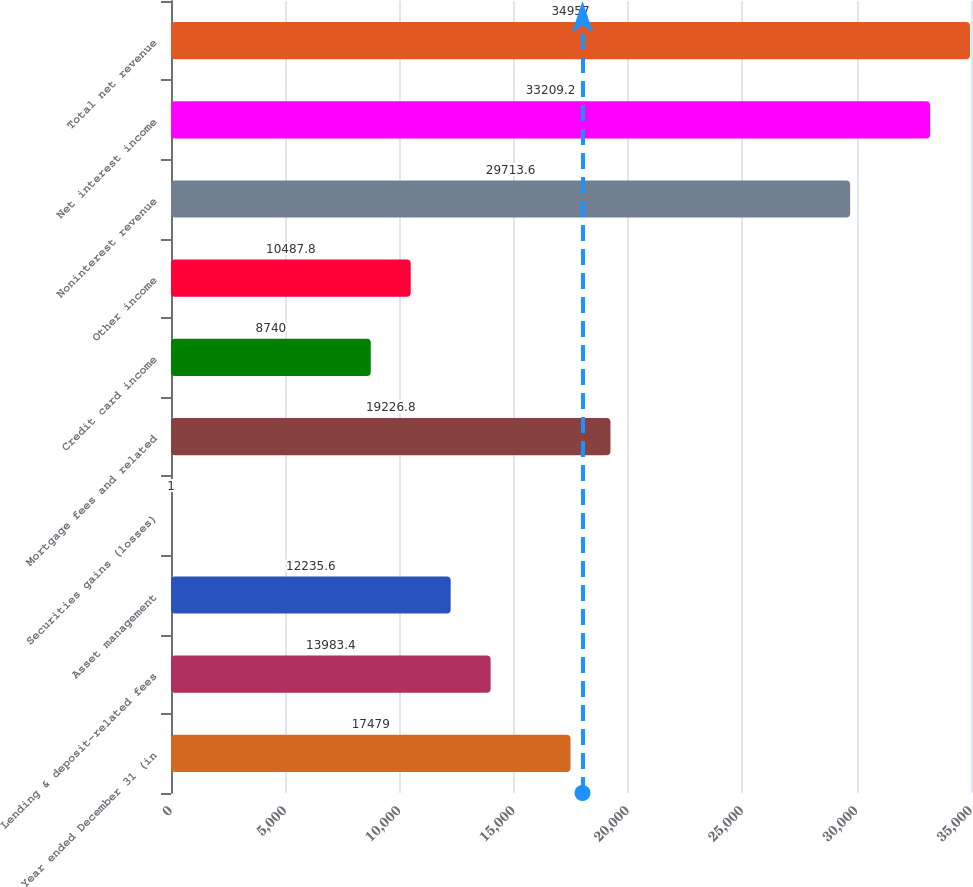Convert chart to OTSL. <chart><loc_0><loc_0><loc_500><loc_500><bar_chart><fcel>Year ended December 31 (in<fcel>Lending & deposit-related fees<fcel>Asset management<fcel>Securities gains (losses)<fcel>Mortgage fees and related<fcel>Credit card income<fcel>Other income<fcel>Noninterest revenue<fcel>Net interest income<fcel>Total net revenue<nl><fcel>17479<fcel>13983.4<fcel>12235.6<fcel>1<fcel>19226.8<fcel>8740<fcel>10487.8<fcel>29713.6<fcel>33209.2<fcel>34957<nl></chart> 